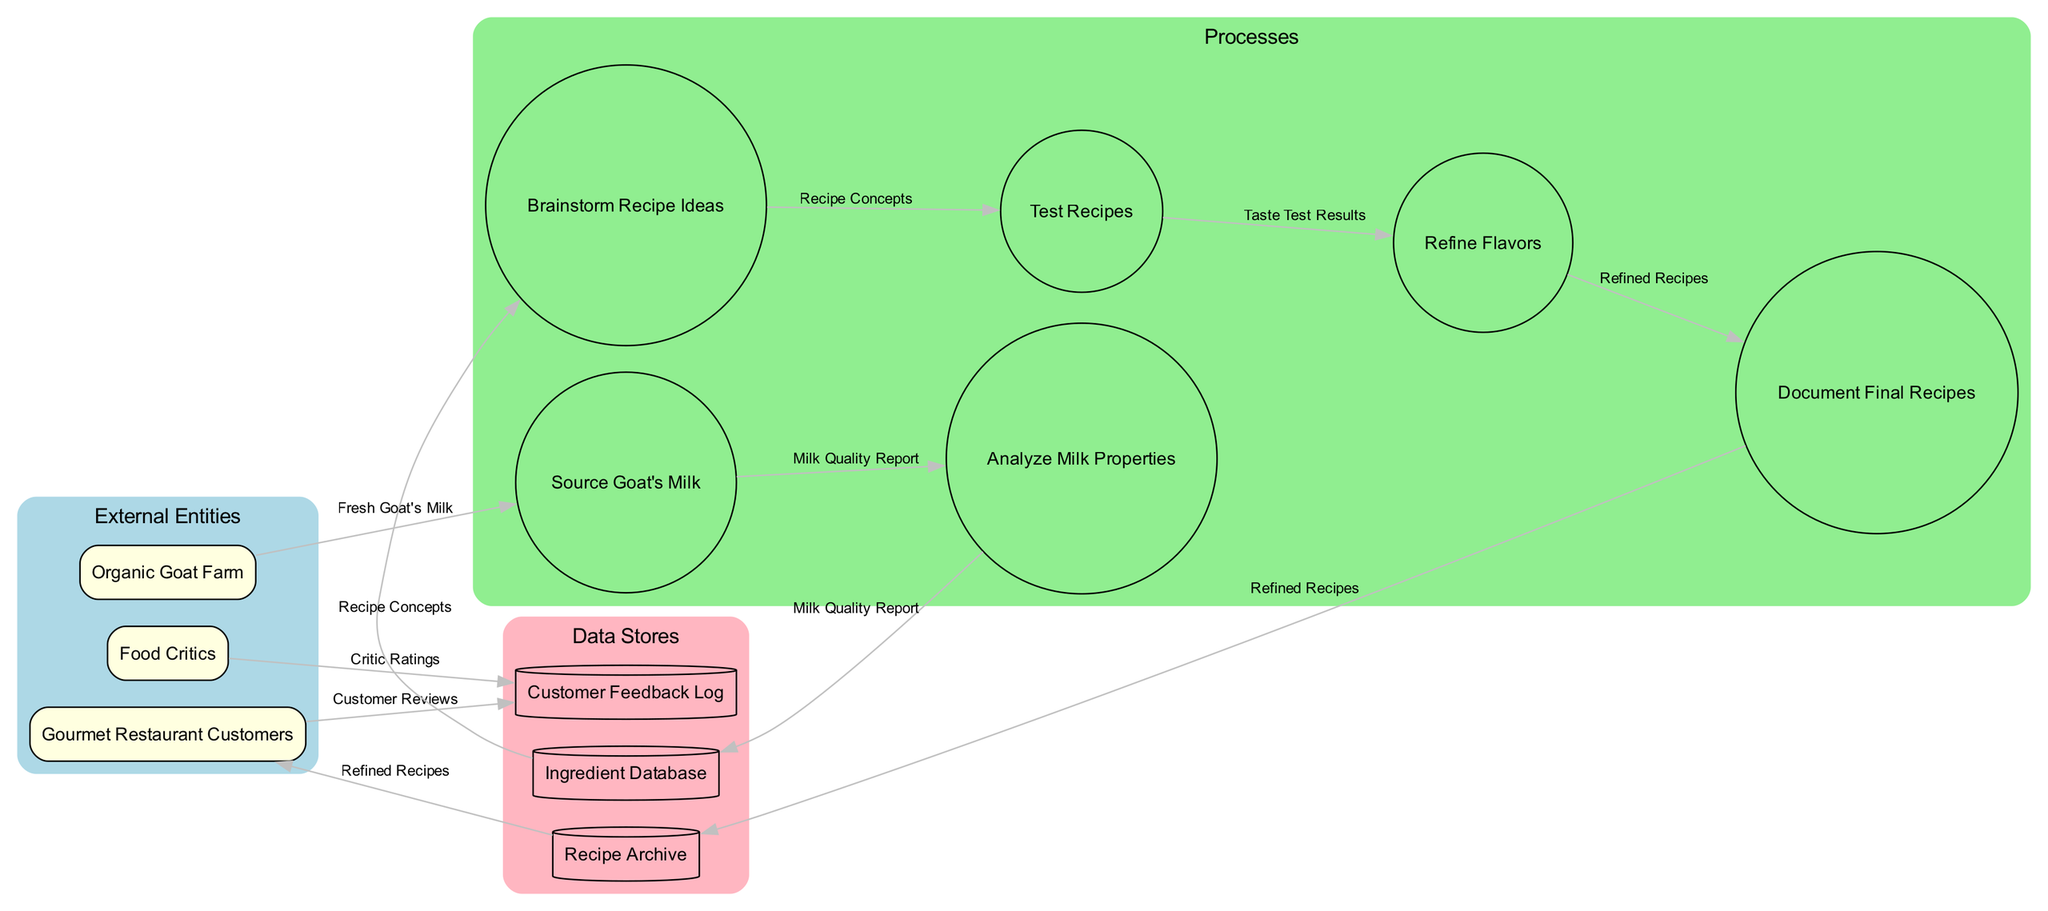What are the external entities in the diagram? The external entities listed in the diagram include "Organic Goat Farm," "Gourmet Restaurant Customers," and "Food Critics." Each of these entities plays a specific role in the recipe development workflow.
Answer: Organic Goat Farm, Gourmet Restaurant Customers, Food Critics How many processes are present in the workflow? The diagram shows a total of 6 processes: "Source Goat's Milk," "Analyze Milk Properties," "Brainstorm Recipe Ideas," "Test Recipes," "Refine Flavors," and "Document Final Recipes." Each of these processes contributes to developing recipes incorporating goat's milk.
Answer: 6 What data flow comes from the 'Source Goat's Milk' process? The data flow that comes from the 'Source Goat's Milk' process is the "Fresh Goat's Milk." This indicates that the output of this process is directly related to the quality of goat's milk sourced.
Answer: Fresh Goat's Milk Which process receives data from 'Analyze Milk Properties'? The next process receiving data from 'Analyze Milk Properties' is the 'Brainstorm Recipe Ideas.' This means that the output from one process is used as input for the subsequent step in the workflow.
Answer: Brainstorm Recipe Ideas What is stored in the 'Recipe Archive'? The 'Recipe Archive' stores "Refined Recipes." After the recipe development process, the refined recipes are documented and stored in this data store for future reference.
Answer: Refined Recipes What is the relationship between 'Gourmet Restaurant Customers' and 'Customer Feedback Log'? The relationship is that the 'Gourmet Restaurant Customers' provide data in the form of "Customer Reviews," which are logged into the 'Customer Feedback Log.' This reflects the importance of customer feedback in refining recipes.
Answer: Customer Reviews How many data flows are involved in the workflow? There are 7 data flows illustrated in the diagram, including 'Fresh Goat's Milk,' 'Milk Quality Report,' 'Recipe Concepts,' 'Taste Test Results,' 'Refined Recipes,' 'Customer Reviews,' and 'Critic Ratings.' Each flow signifies a vital connection in the recipe development process.
Answer: 7 Which data flow is associated with 'Critic Ratings'? The data flow associated with 'Critic Ratings' comes from 'Food Critics,' indicating that critics evaluate the refined recipes, and their ratings are stored or logged in the recipe development workflow.
Answer: Critic Ratings How do 'Test Recipes' and 'Refine Flavors' processes connect? The 'Test Recipes' process leads to the 'Refine Flavors' process through the data flow of "Taste Test Results." This connection highlights how testing influences flavor refinement in recipe development.
Answer: Taste Test Results 